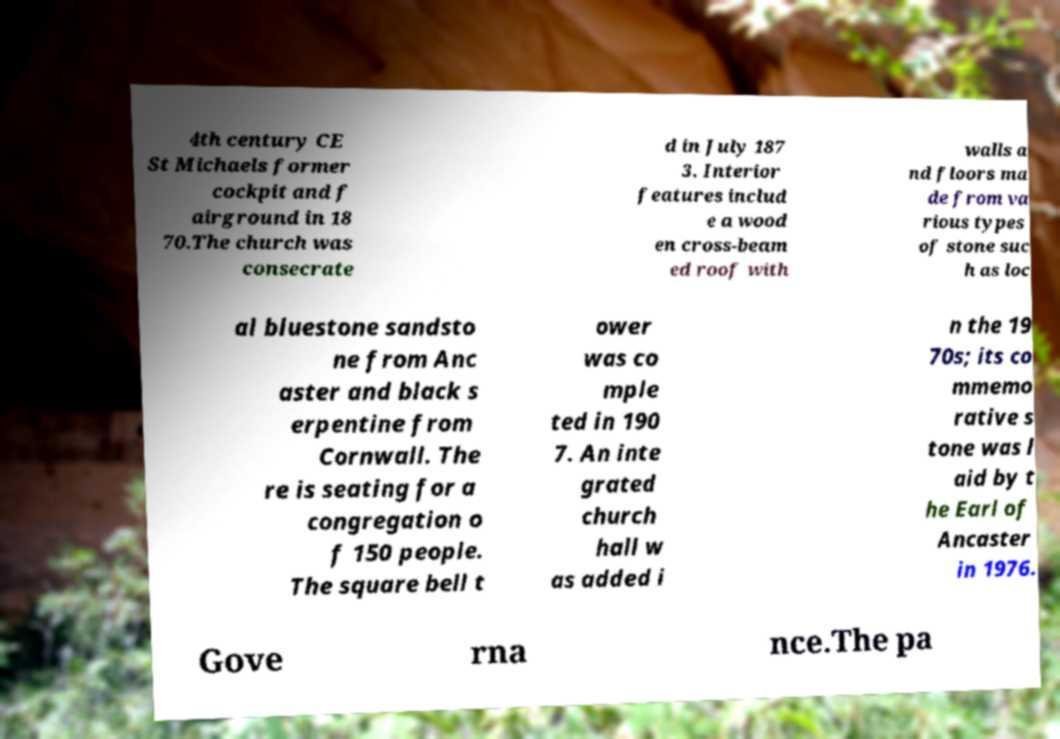For documentation purposes, I need the text within this image transcribed. Could you provide that? 4th century CE St Michaels former cockpit and f airground in 18 70.The church was consecrate d in July 187 3. Interior features includ e a wood en cross-beam ed roof with walls a nd floors ma de from va rious types of stone suc h as loc al bluestone sandsto ne from Anc aster and black s erpentine from Cornwall. The re is seating for a congregation o f 150 people. The square bell t ower was co mple ted in 190 7. An inte grated church hall w as added i n the 19 70s; its co mmemo rative s tone was l aid by t he Earl of Ancaster in 1976. Gove rna nce.The pa 